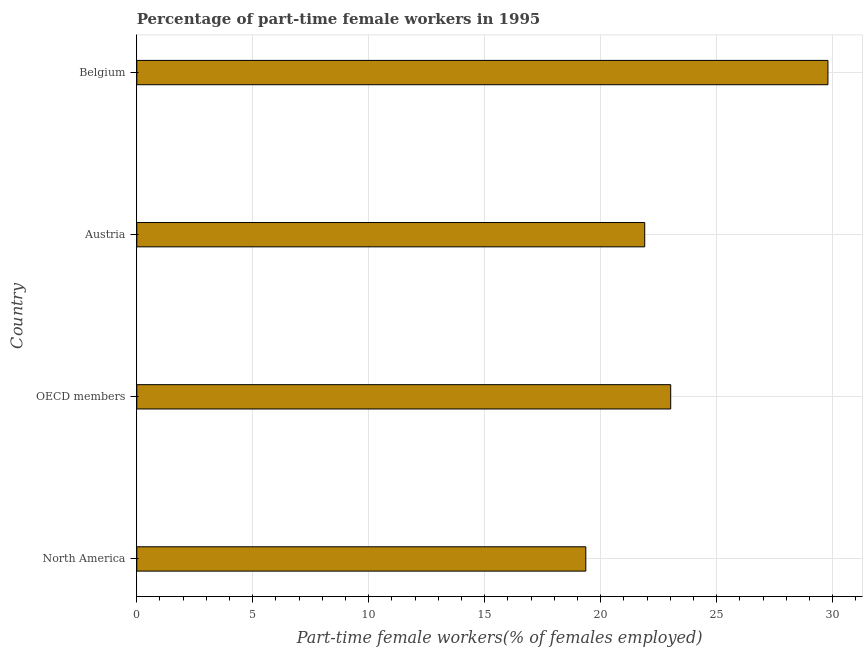Does the graph contain any zero values?
Provide a succinct answer. No. Does the graph contain grids?
Offer a terse response. Yes. What is the title of the graph?
Your answer should be compact. Percentage of part-time female workers in 1995. What is the label or title of the X-axis?
Offer a terse response. Part-time female workers(% of females employed). What is the percentage of part-time female workers in North America?
Give a very brief answer. 19.36. Across all countries, what is the maximum percentage of part-time female workers?
Ensure brevity in your answer.  29.8. Across all countries, what is the minimum percentage of part-time female workers?
Make the answer very short. 19.36. In which country was the percentage of part-time female workers maximum?
Your answer should be compact. Belgium. What is the sum of the percentage of part-time female workers?
Your response must be concise. 94.08. What is the difference between the percentage of part-time female workers in Belgium and North America?
Provide a short and direct response. 10.44. What is the average percentage of part-time female workers per country?
Offer a terse response. 23.52. What is the median percentage of part-time female workers?
Make the answer very short. 22.46. What is the ratio of the percentage of part-time female workers in Belgium to that in OECD members?
Ensure brevity in your answer.  1.29. What is the difference between the highest and the second highest percentage of part-time female workers?
Offer a terse response. 6.78. Is the sum of the percentage of part-time female workers in Austria and OECD members greater than the maximum percentage of part-time female workers across all countries?
Your answer should be compact. Yes. What is the difference between the highest and the lowest percentage of part-time female workers?
Offer a terse response. 10.44. How many bars are there?
Your response must be concise. 4. How many countries are there in the graph?
Make the answer very short. 4. What is the difference between two consecutive major ticks on the X-axis?
Your answer should be compact. 5. Are the values on the major ticks of X-axis written in scientific E-notation?
Offer a very short reply. No. What is the Part-time female workers(% of females employed) of North America?
Your answer should be compact. 19.36. What is the Part-time female workers(% of females employed) in OECD members?
Offer a terse response. 23.02. What is the Part-time female workers(% of females employed) in Austria?
Your answer should be very brief. 21.9. What is the Part-time female workers(% of females employed) in Belgium?
Provide a short and direct response. 29.8. What is the difference between the Part-time female workers(% of females employed) in North America and OECD members?
Provide a short and direct response. -3.66. What is the difference between the Part-time female workers(% of females employed) in North America and Austria?
Your answer should be very brief. -2.54. What is the difference between the Part-time female workers(% of females employed) in North America and Belgium?
Offer a terse response. -10.44. What is the difference between the Part-time female workers(% of females employed) in OECD members and Austria?
Your answer should be very brief. 1.12. What is the difference between the Part-time female workers(% of females employed) in OECD members and Belgium?
Your answer should be very brief. -6.78. What is the difference between the Part-time female workers(% of females employed) in Austria and Belgium?
Offer a very short reply. -7.9. What is the ratio of the Part-time female workers(% of females employed) in North America to that in OECD members?
Make the answer very short. 0.84. What is the ratio of the Part-time female workers(% of females employed) in North America to that in Austria?
Keep it short and to the point. 0.88. What is the ratio of the Part-time female workers(% of females employed) in North America to that in Belgium?
Offer a very short reply. 0.65. What is the ratio of the Part-time female workers(% of females employed) in OECD members to that in Austria?
Your answer should be compact. 1.05. What is the ratio of the Part-time female workers(% of females employed) in OECD members to that in Belgium?
Your answer should be very brief. 0.77. What is the ratio of the Part-time female workers(% of females employed) in Austria to that in Belgium?
Make the answer very short. 0.73. 